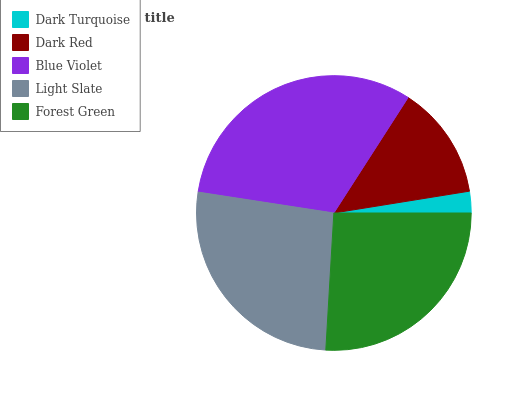Is Dark Turquoise the minimum?
Answer yes or no. Yes. Is Blue Violet the maximum?
Answer yes or no. Yes. Is Dark Red the minimum?
Answer yes or no. No. Is Dark Red the maximum?
Answer yes or no. No. Is Dark Red greater than Dark Turquoise?
Answer yes or no. Yes. Is Dark Turquoise less than Dark Red?
Answer yes or no. Yes. Is Dark Turquoise greater than Dark Red?
Answer yes or no. No. Is Dark Red less than Dark Turquoise?
Answer yes or no. No. Is Forest Green the high median?
Answer yes or no. Yes. Is Forest Green the low median?
Answer yes or no. Yes. Is Blue Violet the high median?
Answer yes or no. No. Is Dark Turquoise the low median?
Answer yes or no. No. 